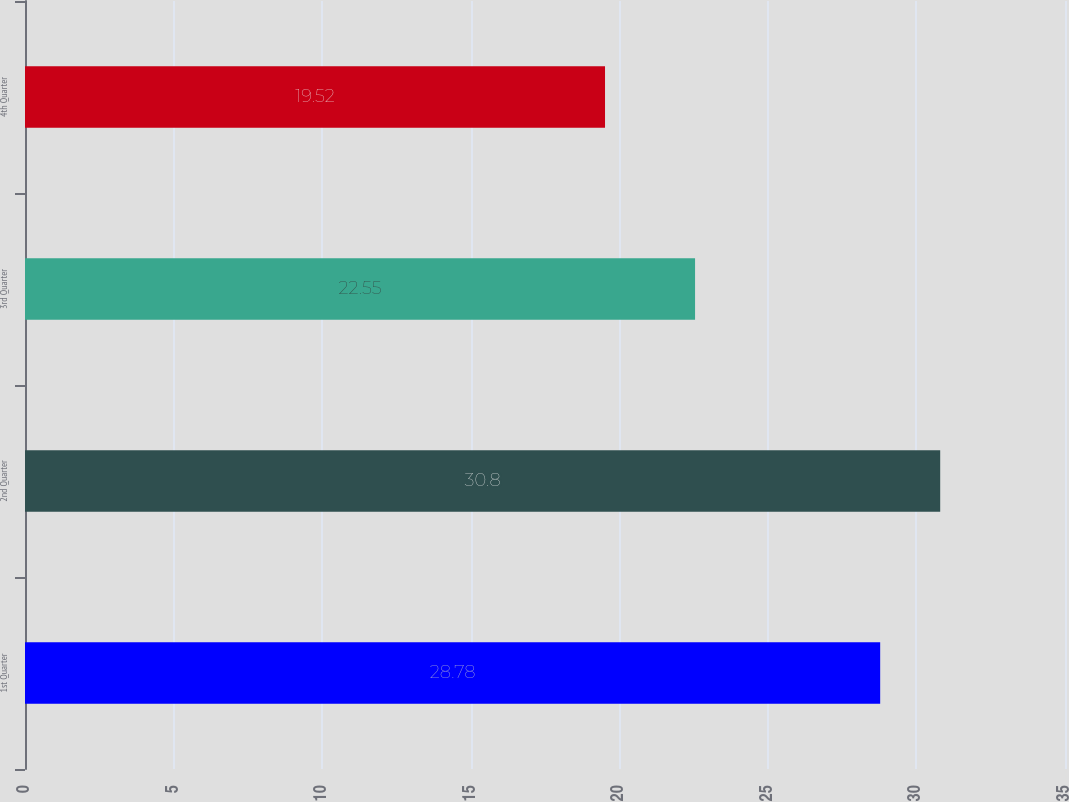Convert chart. <chart><loc_0><loc_0><loc_500><loc_500><bar_chart><fcel>1st Quarter<fcel>2nd Quarter<fcel>3rd Quarter<fcel>4th Quarter<nl><fcel>28.78<fcel>30.8<fcel>22.55<fcel>19.52<nl></chart> 